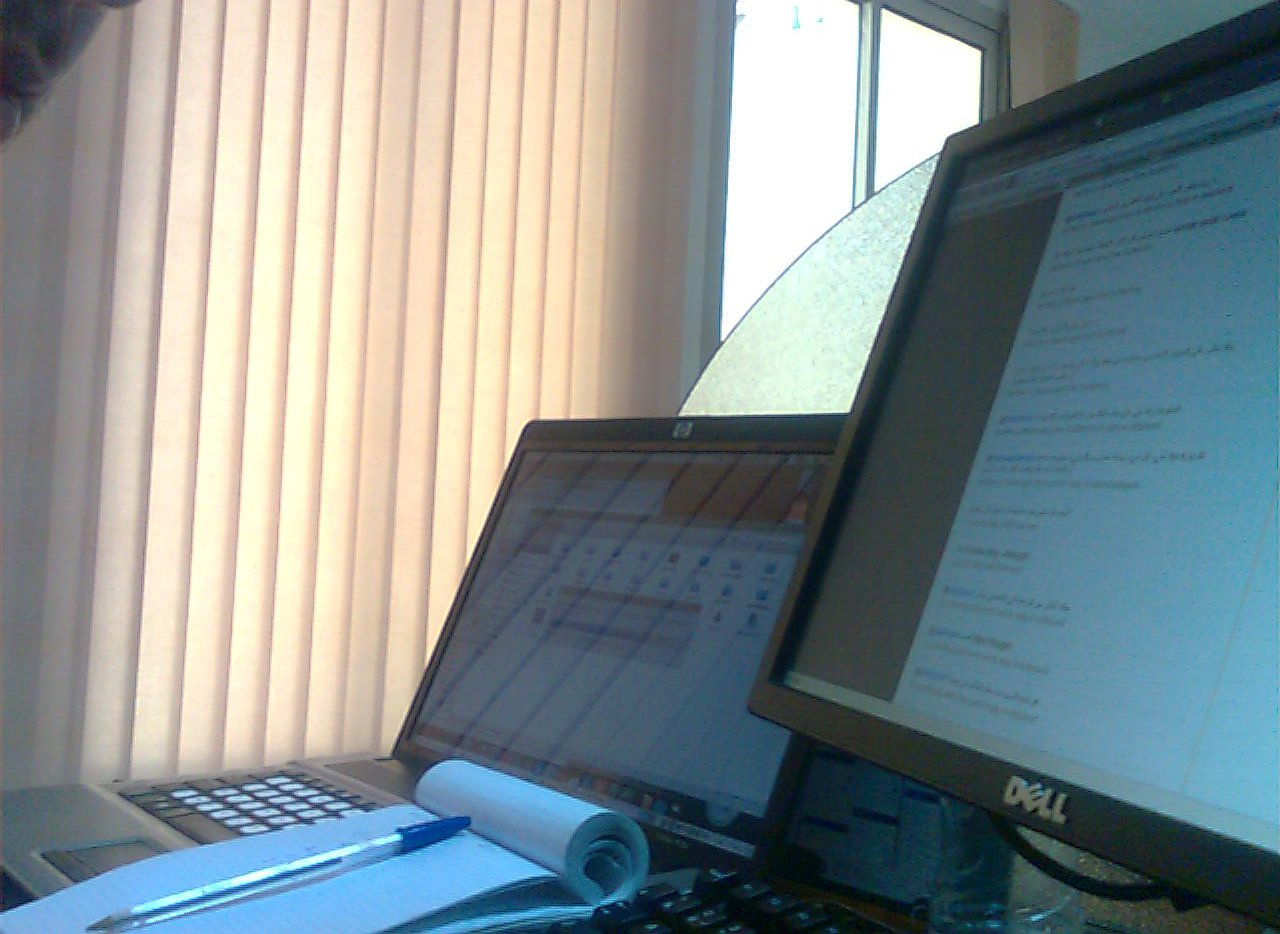Is the computer monitor to the right of a computer? No, the computer monitor is not situated to the right of another computer; it stands alone as the primary display. 